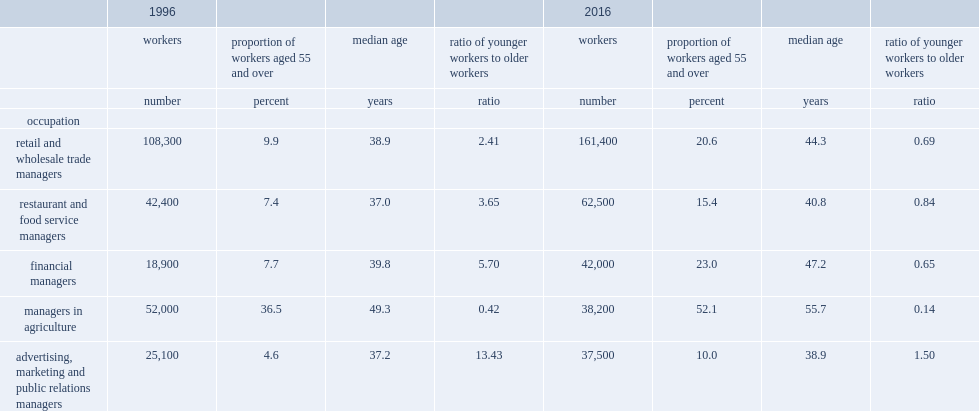What is the percentage of female managers in agriculture aged 55 and over among all female managers in agriculture in 2016? 52.1. What is the percentage of female managers in agriculture aged 55 and over among all female managers in agriculture in 1996? 36.5. What is the percentage of women employed as advertising, marketing and public relations managers aged 55 and over in 2016? 10.0. What is the percentage of women employed as advertising, marketing and public relations managers aged 55 and over in 1996? 4.6. 